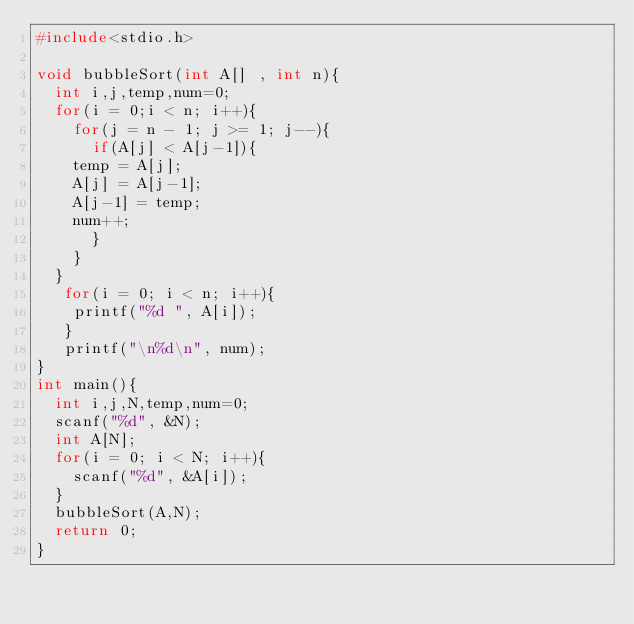Convert code to text. <code><loc_0><loc_0><loc_500><loc_500><_C_>#include<stdio.h>

void bubbleSort(int A[] , int n){
  int i,j,temp,num=0;
  for(i = 0;i < n; i++){
    for(j = n - 1; j >= 1; j--){
      if(A[j] < A[j-1]){
	temp = A[j];
	A[j] = A[j-1];
	A[j-1] = temp;
	num++;
      }
    }
  }
   for(i = 0; i < n; i++){
    printf("%d ", A[i]);
   }
   printf("\n%d\n", num);
}
int main(){
  int i,j,N,temp,num=0;
  scanf("%d", &N);
  int A[N];
  for(i = 0; i < N; i++){
    scanf("%d", &A[i]);
  }
  bubbleSort(A,N);
  return 0;
}</code> 